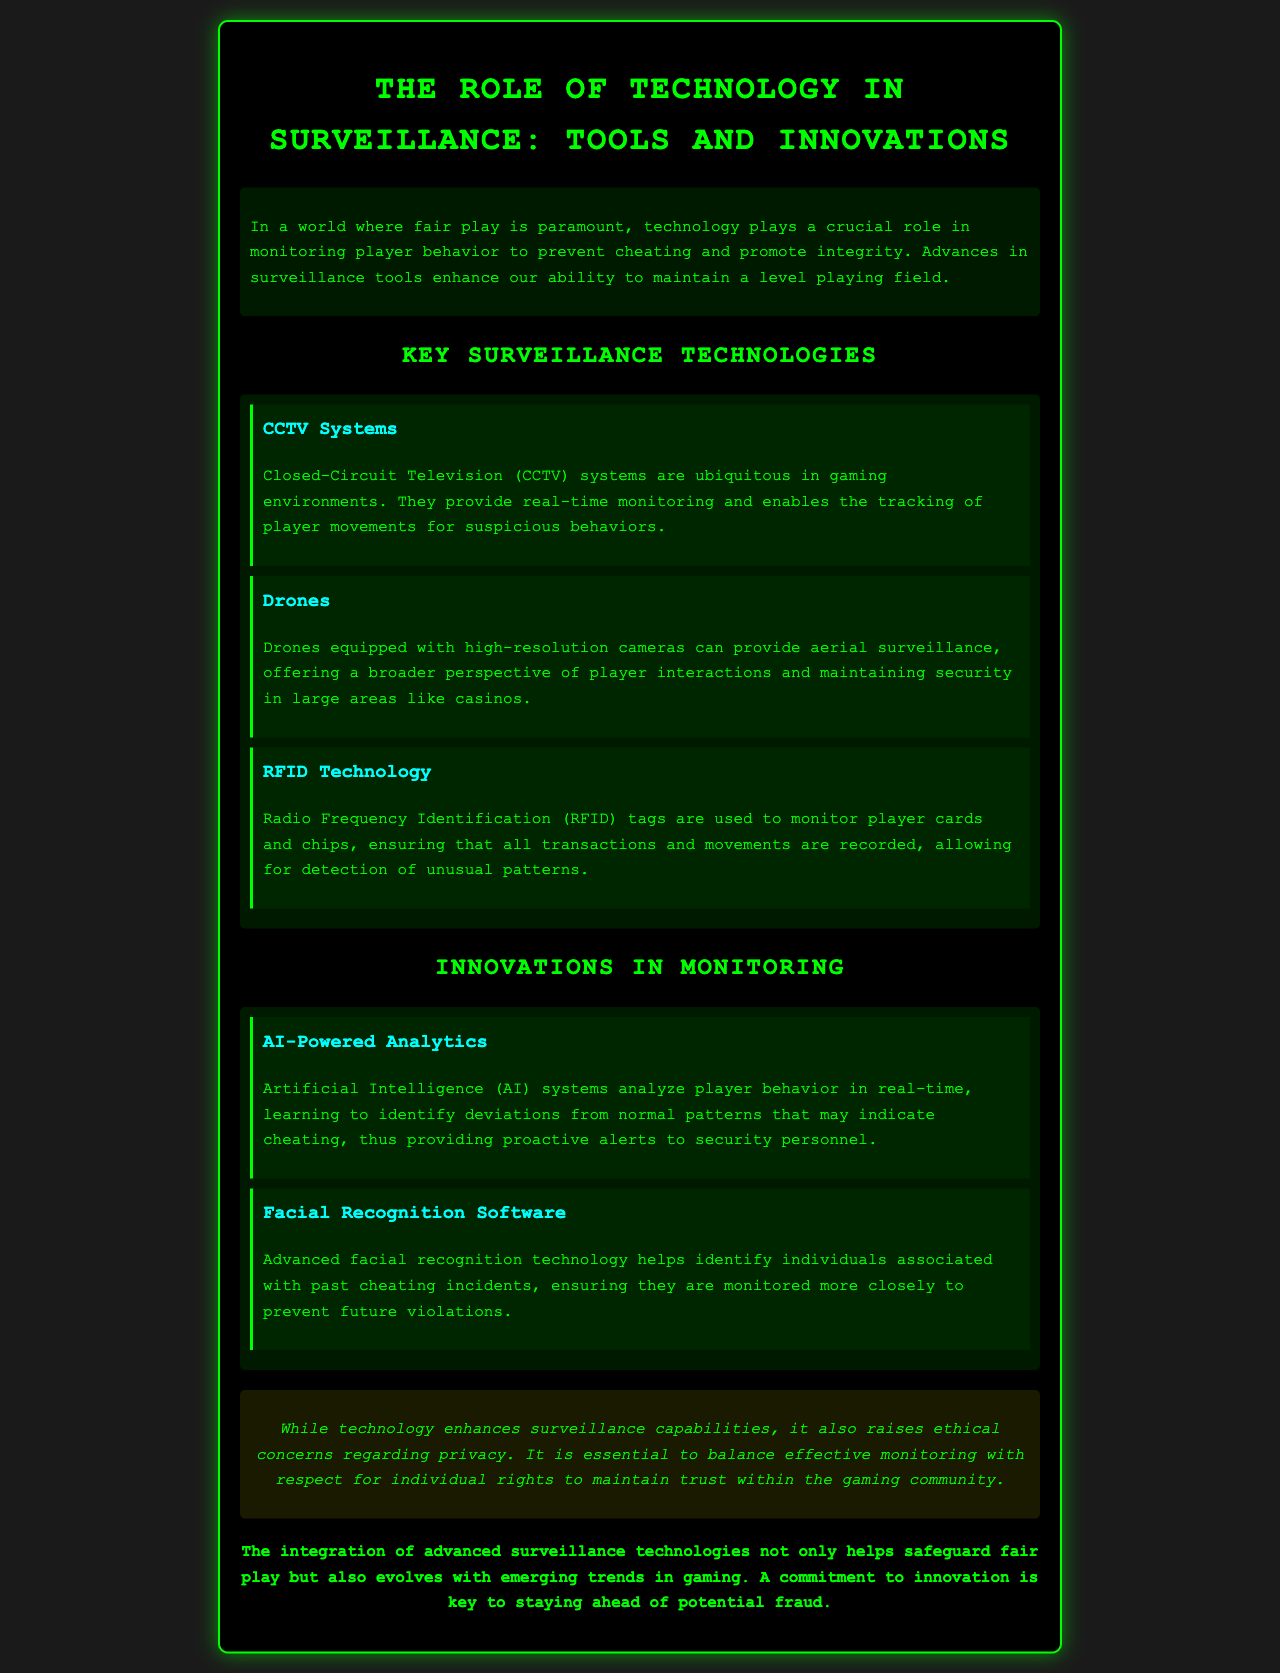What is the title of the brochure? The title is located at the top of the document and reflects the main theme of the content.
Answer: The Role of Technology in Surveillance: Tools and Innovations What technology provides real-time monitoring? This information can be retrieved from the section discussing key surveillance technologies.
Answer: CCTV Systems What is used to track player cards and chips? The document explicitly mentions this technology in relation to monitoring transactions and movements.
Answer: RFID Technology What does AI-powered analytics help identify? This information is found in the section discussing innovations in monitoring, relating to identification of specific player behaviors.
Answer: Deviations What is the main ethical concern regarding surveillance technology? The document discusses this in the ethical section, highlighting the balance needed in monitoring practices.
Answer: Privacy How many key surveillance technologies are listed? This can be determined by counting the technologies mentioned in the key surveillance technologies section.
Answer: Three What type of software helps monitor individuals with past cheating incidents? This specific type of technology is mentioned in the innovations section regarding surveillance measures.
Answer: Facial Recognition Software What is essential to maintain trust within the gaming community? This information is derived from the ethical consideration outlined in the brochure.
Answer: Respect for individual rights What does the conclusion emphasize about surveillance technologies? The conclusion summarizes the document’s stance on the significance of evolving practices in surveillance.
Answer: Safeguard fair play 